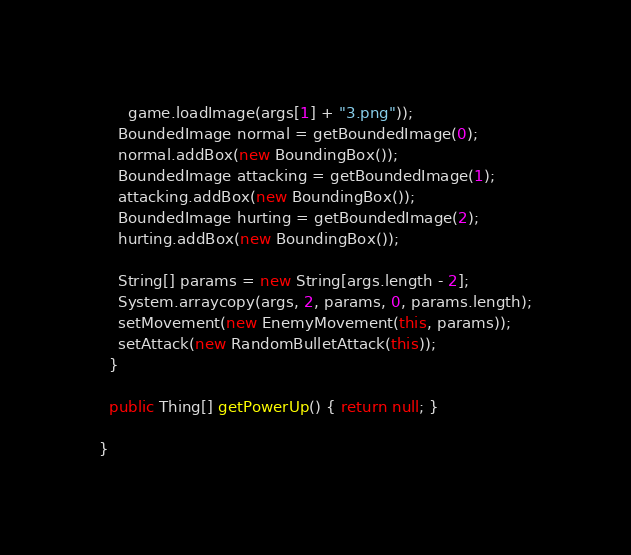Convert code to text. <code><loc_0><loc_0><loc_500><loc_500><_Java_>      game.loadImage(args[1] + "3.png"));
    BoundedImage normal = getBoundedImage(0);
    normal.addBox(new BoundingBox());
    BoundedImage attacking = getBoundedImage(1);
    attacking.addBox(new BoundingBox());
    BoundedImage hurting = getBoundedImage(2);
    hurting.addBox(new BoundingBox());

    String[] params = new String[args.length - 2];
    System.arraycopy(args, 2, params, 0, params.length);
    setMovement(new EnemyMovement(this, params));
    setAttack(new RandomBulletAttack(this));
  }

  public Thing[] getPowerUp() { return null; }

}
</code> 